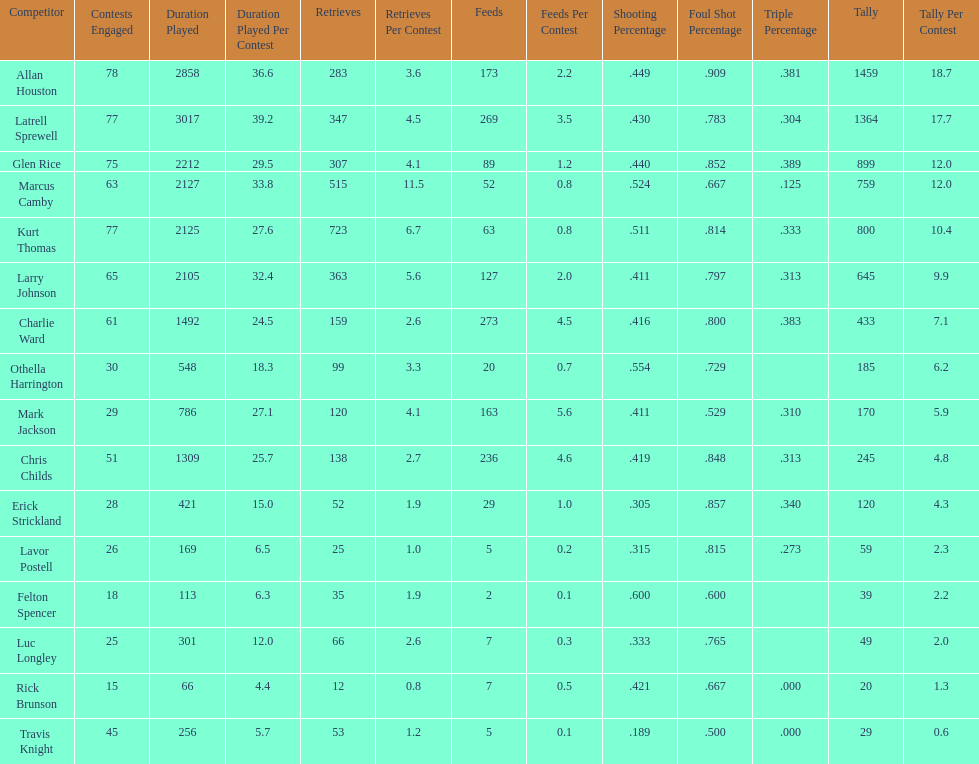How many total points were scored by players averaging over 4 assists per game> 848. 